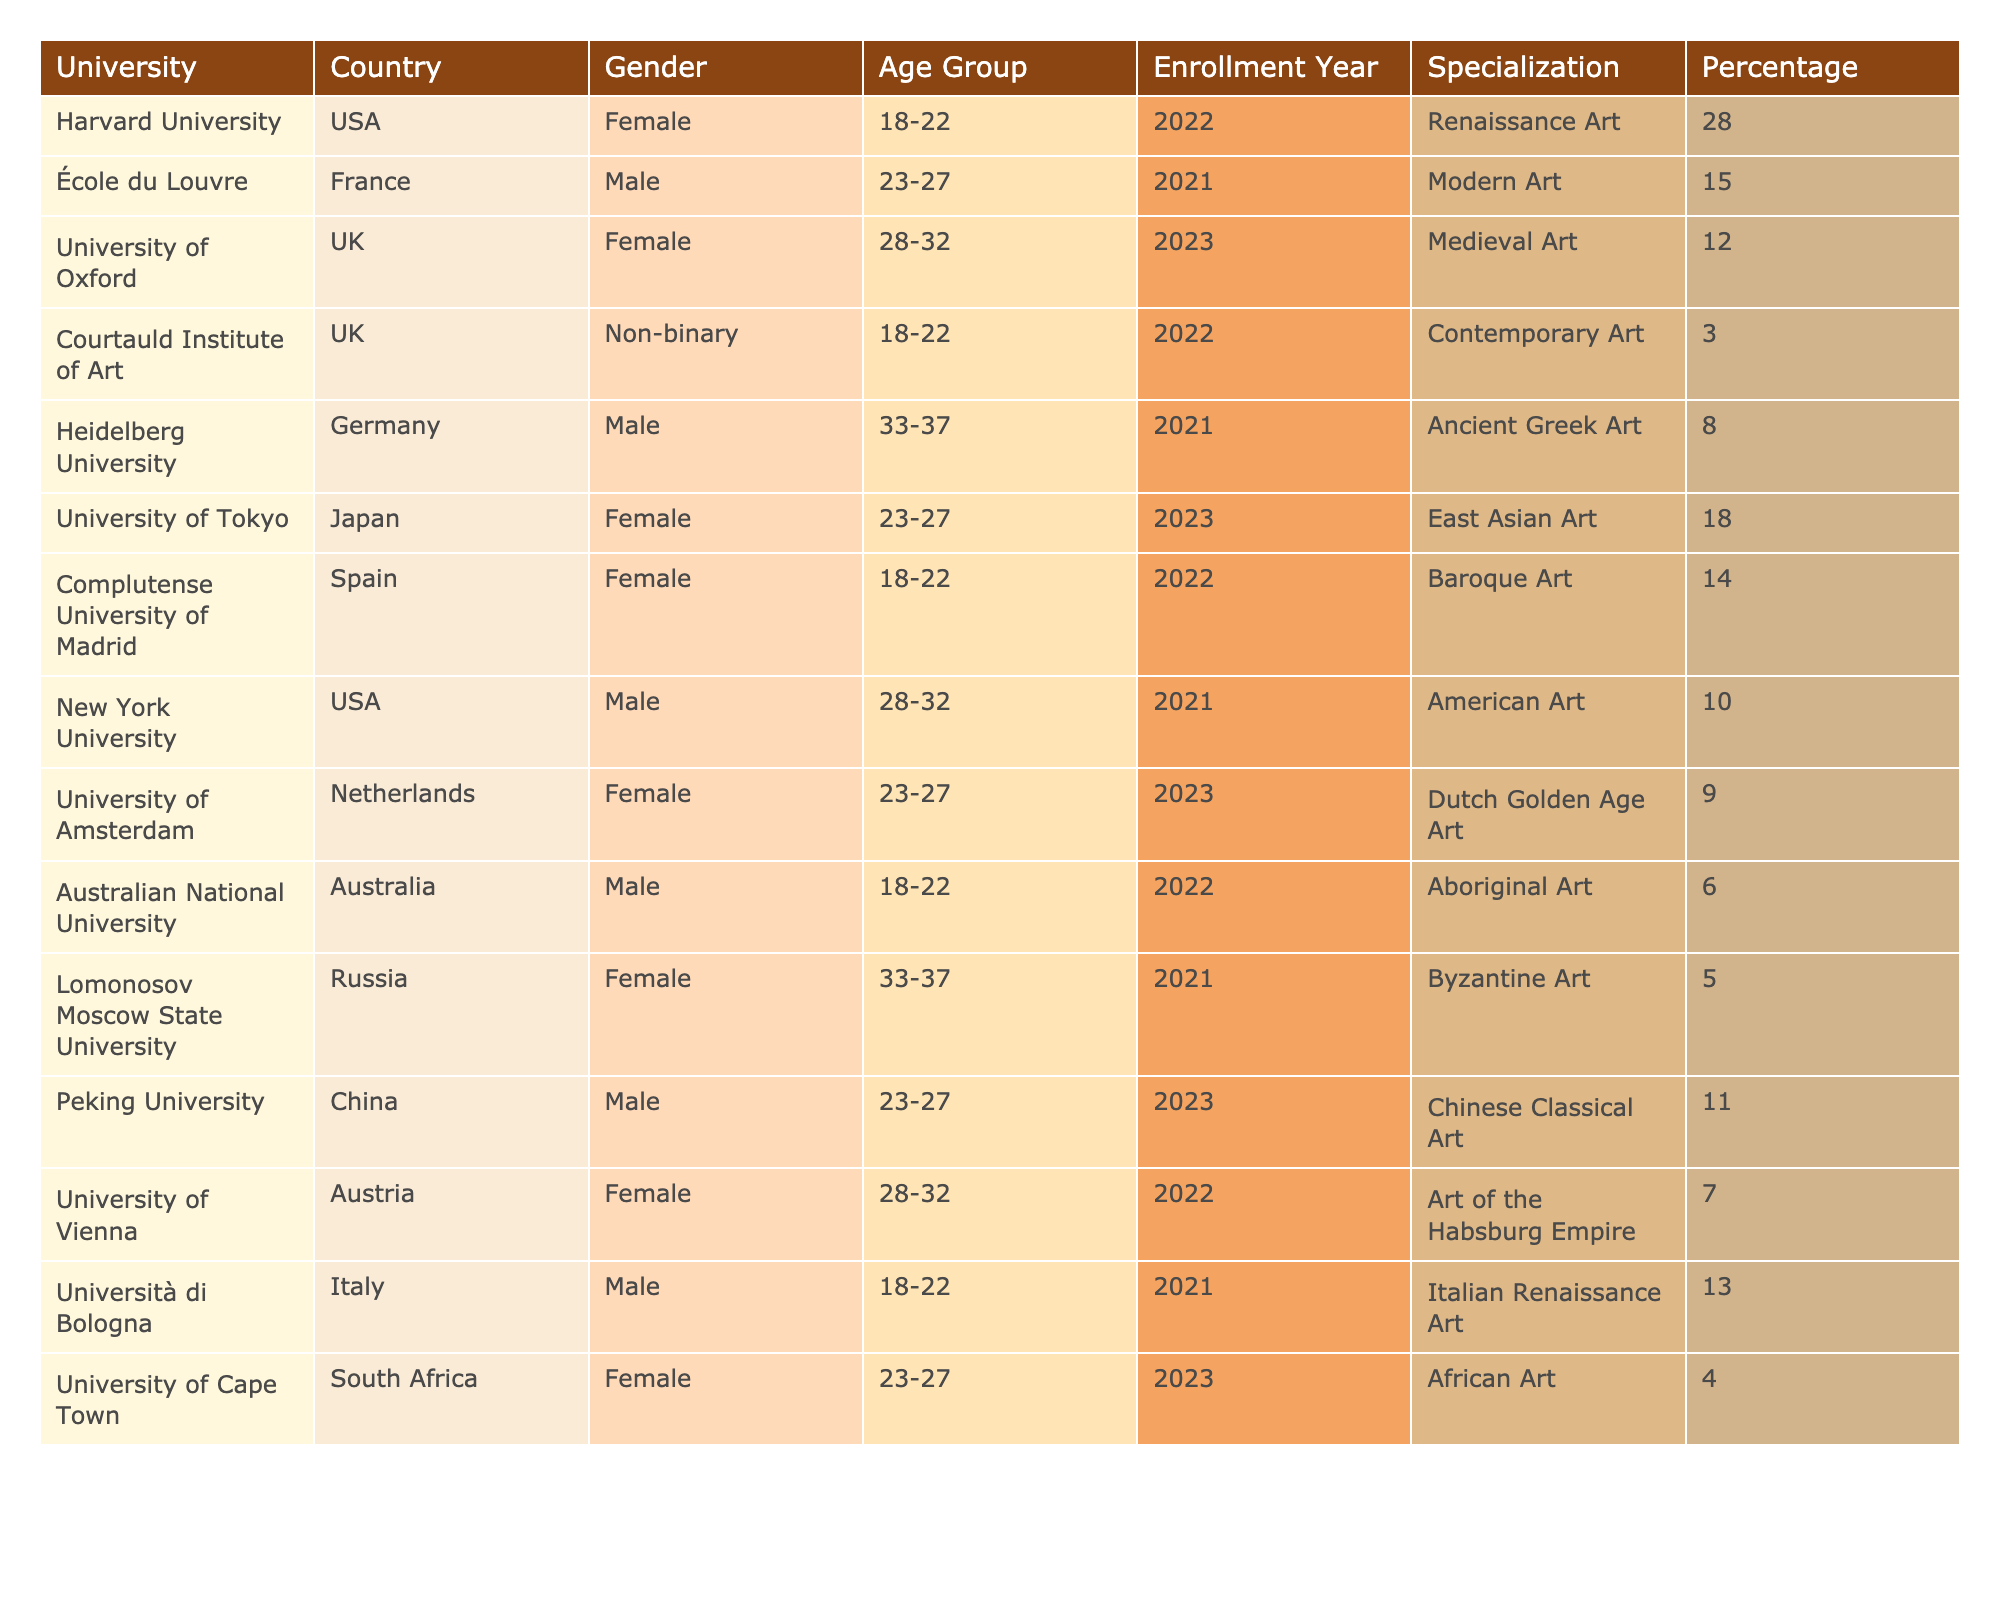What is the percentage of art history students from Harvard University? The percentage for Harvard University is directly provided in the table, which states that 28% of its art history students are female.
Answer: 28% Which age group has the highest representation of students in the table? By examining the age groups listed, the 18-22 age group appears most frequently. Counting the entries shows there are 5 students in this age group, which is greater than other age groups.
Answer: 18-22 How many male students are enrolled in total across all universities? By summing the percentages of male students from each university listed in the table, we find the totals: 15% (École du Louvre) + 8% (Heidelberg University) + 10% (New York University) + 11% (Peking University) + 6% (Australian National University) + 13% (Università di Bologna) = 63%.
Answer: 63% Is there any non-binary representation among the students listed? Checking the table, there is an entry under Courtauld Institute of Art with a non-binary student, indicating that yes, there is non-binary representation among the students.
Answer: Yes What percentage of students at the University of Tokyo are female? The table indicates that the University of Tokyo has 18% of its students as female enrolled in East Asian Art specialization.
Answer: 18% What is the average percentage of students in the age group 23-27? To find the average for the age group 23-27, sum the percentages from the relevant entries: 15% (École du Louvre) + 18% (University of Tokyo) + 9% (University of Amsterdam) + 11% (Peking University) + 4% (University of Cape Town) = 57%. Then, divide by the number of entries, which is 5: 57% / 5 = 11.4%.
Answer: 11.4% Which country has the least representation among the art history students listed? Looking over the table, the entry with the least percentage is Lomonosov Moscow State University from Russia, which has 5% of students studying Byzantine Art.
Answer: Russia Are there more female students than male students combined in this list? By summing the percentages of females (28 + 12 + 18 + 14 + 9 + 7 + 4 = 92%) and comparing it to total male percentages (15 + 8 + 10 + 11 + 6 + 13 = 63%), we see that females hold a higher percentage of representation.
Answer: Yes What is the combined percentage of students specializing in Ancient Greek Art and Chinese Classical Art? Adding the respective percentages gives: 8% (Heidelberg University, Ancient Greek Art) + 11% (Peking University, Chinese Classical Art) = 19%.
Answer: 19% What percentage of students at Courtauld Institute of Art specialize in Contemporary Art? Directly from the table, the percentage of students at the Courtauld Institute of Art specializing in Contemporary Art is 3%.
Answer: 3% 